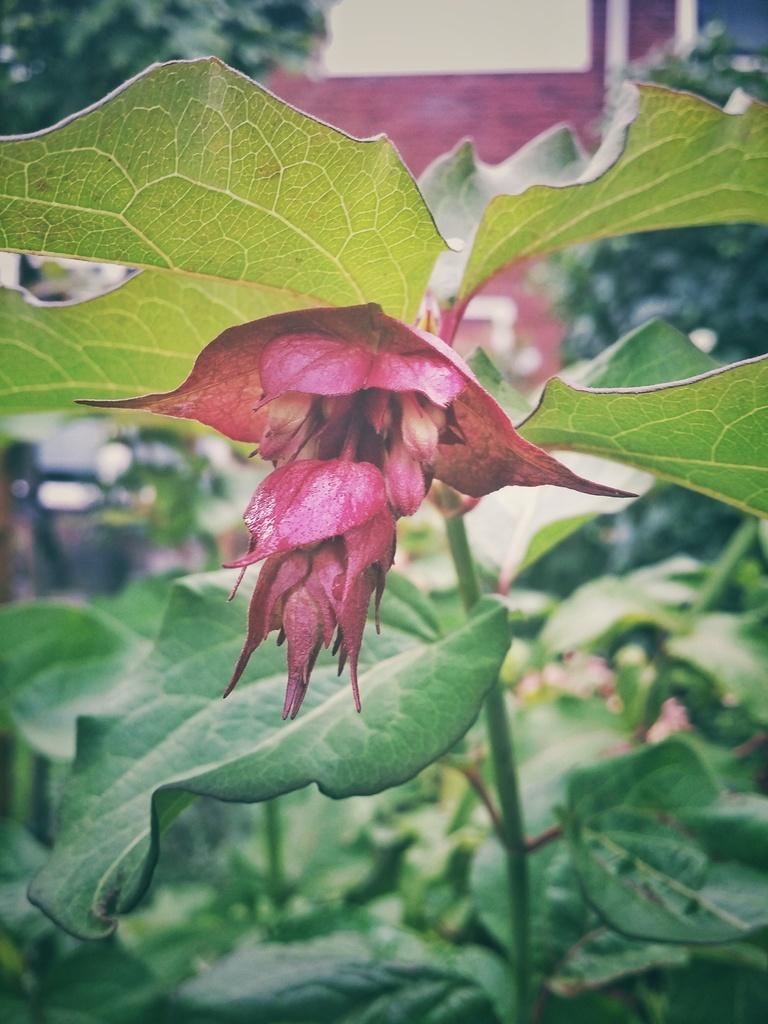What type of plant is visible in the image? There is a flower on a plant visible in the image. What type of structure can be seen in the image? There is a building in the image. What else is present in the image besides the plant and building? Pipelines are present in the image. Can you tell me how many beetles are playing chess on the building in the image? There are no beetles or chess games present in the image. 